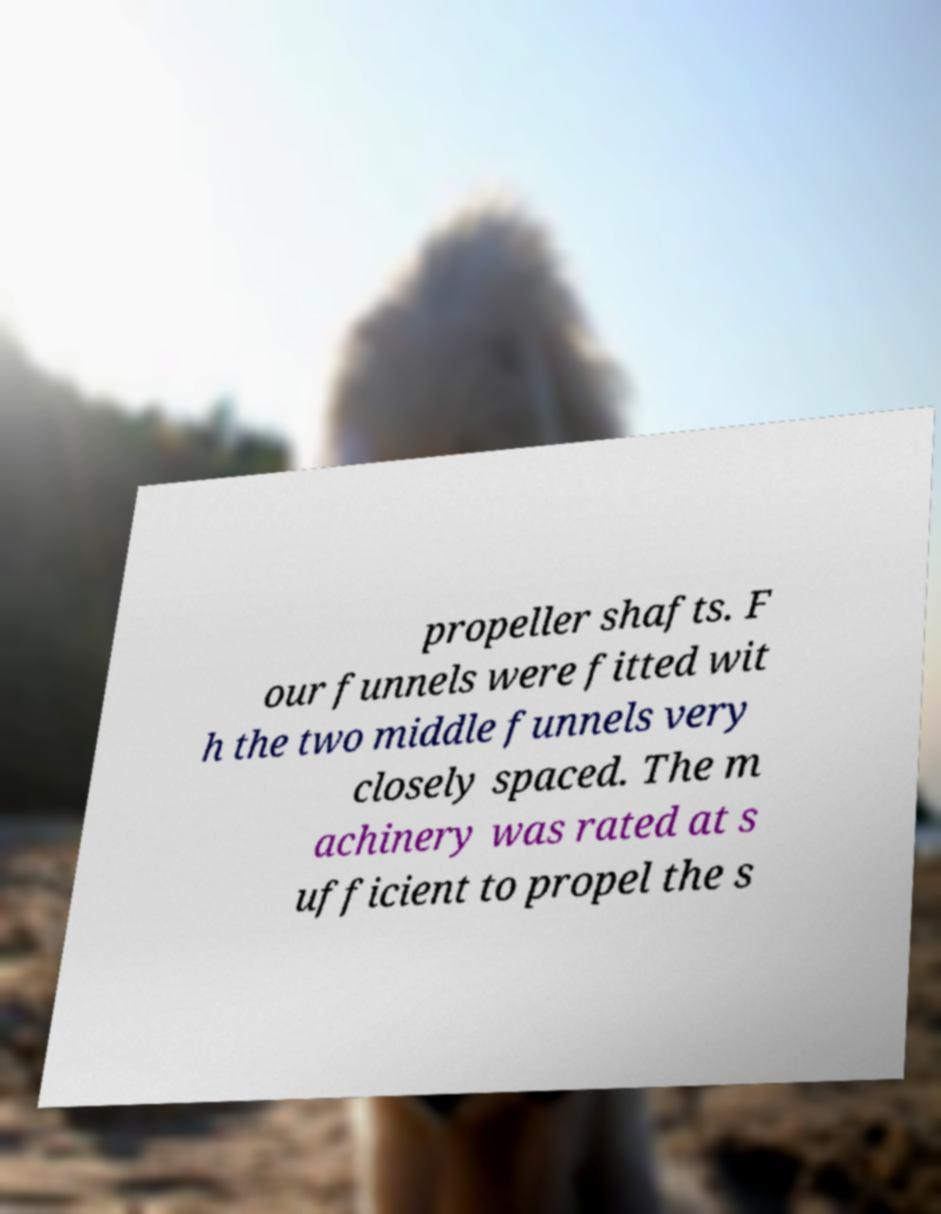I need the written content from this picture converted into text. Can you do that? propeller shafts. F our funnels were fitted wit h the two middle funnels very closely spaced. The m achinery was rated at s ufficient to propel the s 